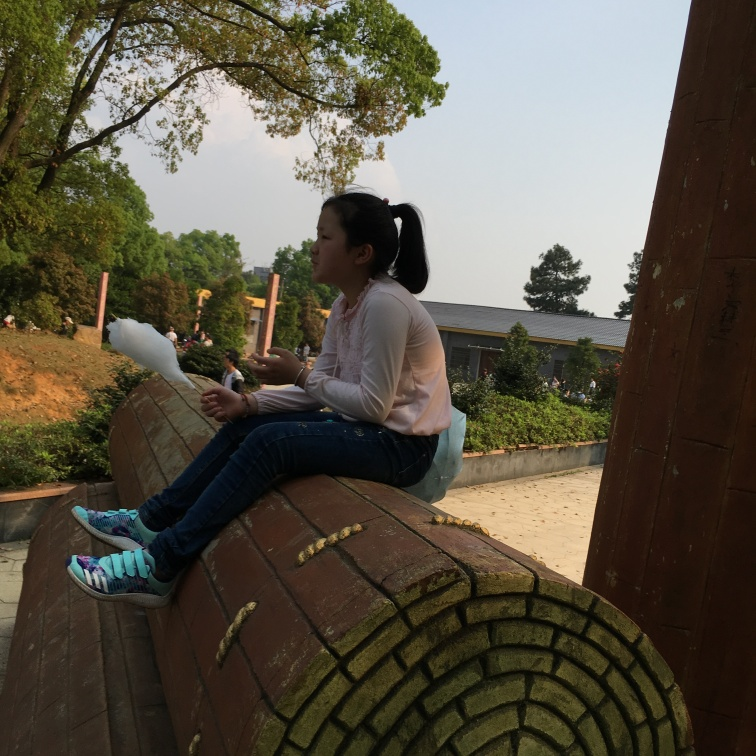What time of day does it seem to be in this image? Given the lighting and the length of the shadows present in the image, it appears to be late afternoon. The warm color tones suggest that the sun is on its way to setting, which is consistent with the relaxed atmosphere in the photo. 